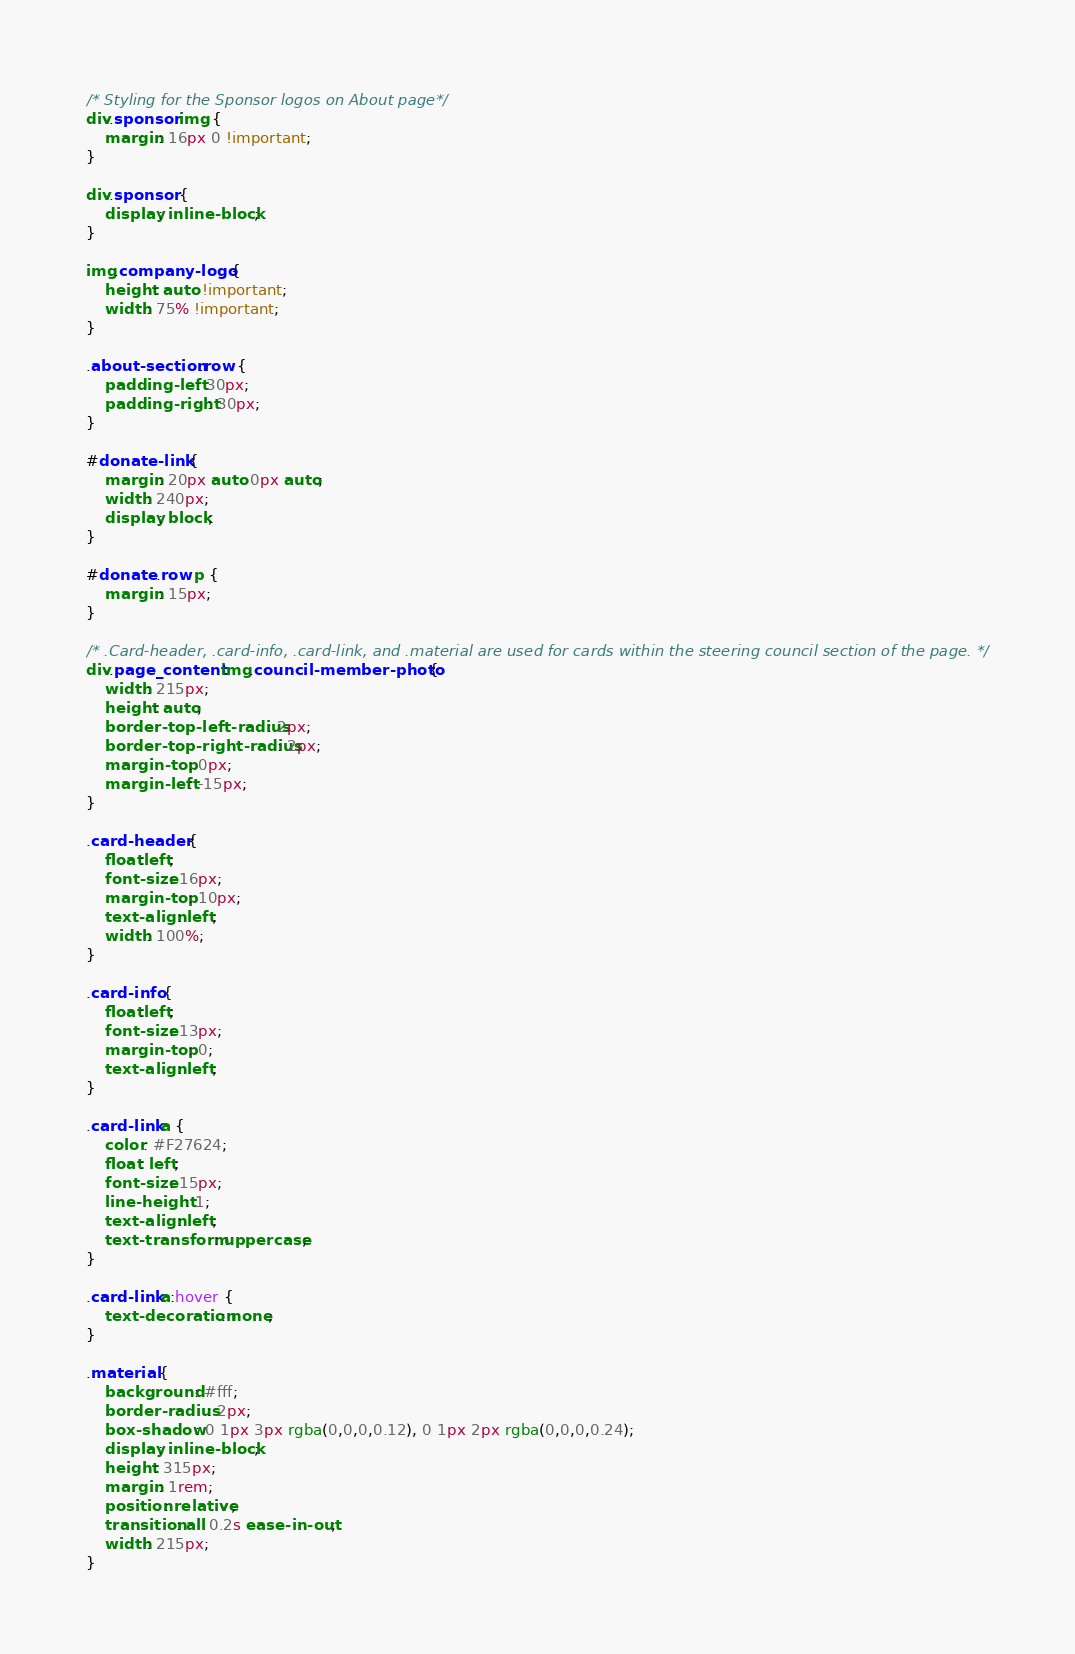<code> <loc_0><loc_0><loc_500><loc_500><_CSS_>/* Styling for the Sponsor logos on About page*/
div.sponsor img {
    margin: 16px 0 !important;
}

div.sponsor {
    display: inline-block;
}

img.company-logo {
    height: auto !important;
    width: 75% !important;
}

.about-section .row {
    padding-left: 30px;
    padding-right: 30px;
}

#donate-link {
    margin: 20px auto 0px auto;
    width: 240px;
    display: block;
}

#donate .row p {
    margin: 15px;
}

/* .Card-header, .card-info, .card-link, and .material are used for cards within the steering council section of the page. */
div.page_content img.council-member-photo {
    width: 215px;
    height: auto;
    border-top-left-radius: 2px;
    border-top-right-radius: 2px;
    margin-top: 0px;
    margin-left: -15px;
}

.card-header {
    float:left;
    font-size: 16px;
    margin-top: 10px;
    text-align: left;
    width: 100%;
}

.card-info {
    float:left;
    font-size: 13px;
    margin-top: 0;
    text-align: left;
}

.card-link a {
    color: #F27624;
    float: left;
    font-size: 15px;
    line-height: 1;
    text-align: left;
    text-transform: uppercase;
}

.card-link a:hover {
    text-decoration: none;
}

.material {
    background: #fff;
    border-radius: 2px;
    box-shadow: 0 1px 3px rgba(0,0,0,0.12), 0 1px 2px rgba(0,0,0,0.24);
    display: inline-block;
    height: 315px;
    margin: 1rem;
    position: relative;
    transition: all 0.2s ease-in-out;
    width: 215px;
}
</code> 